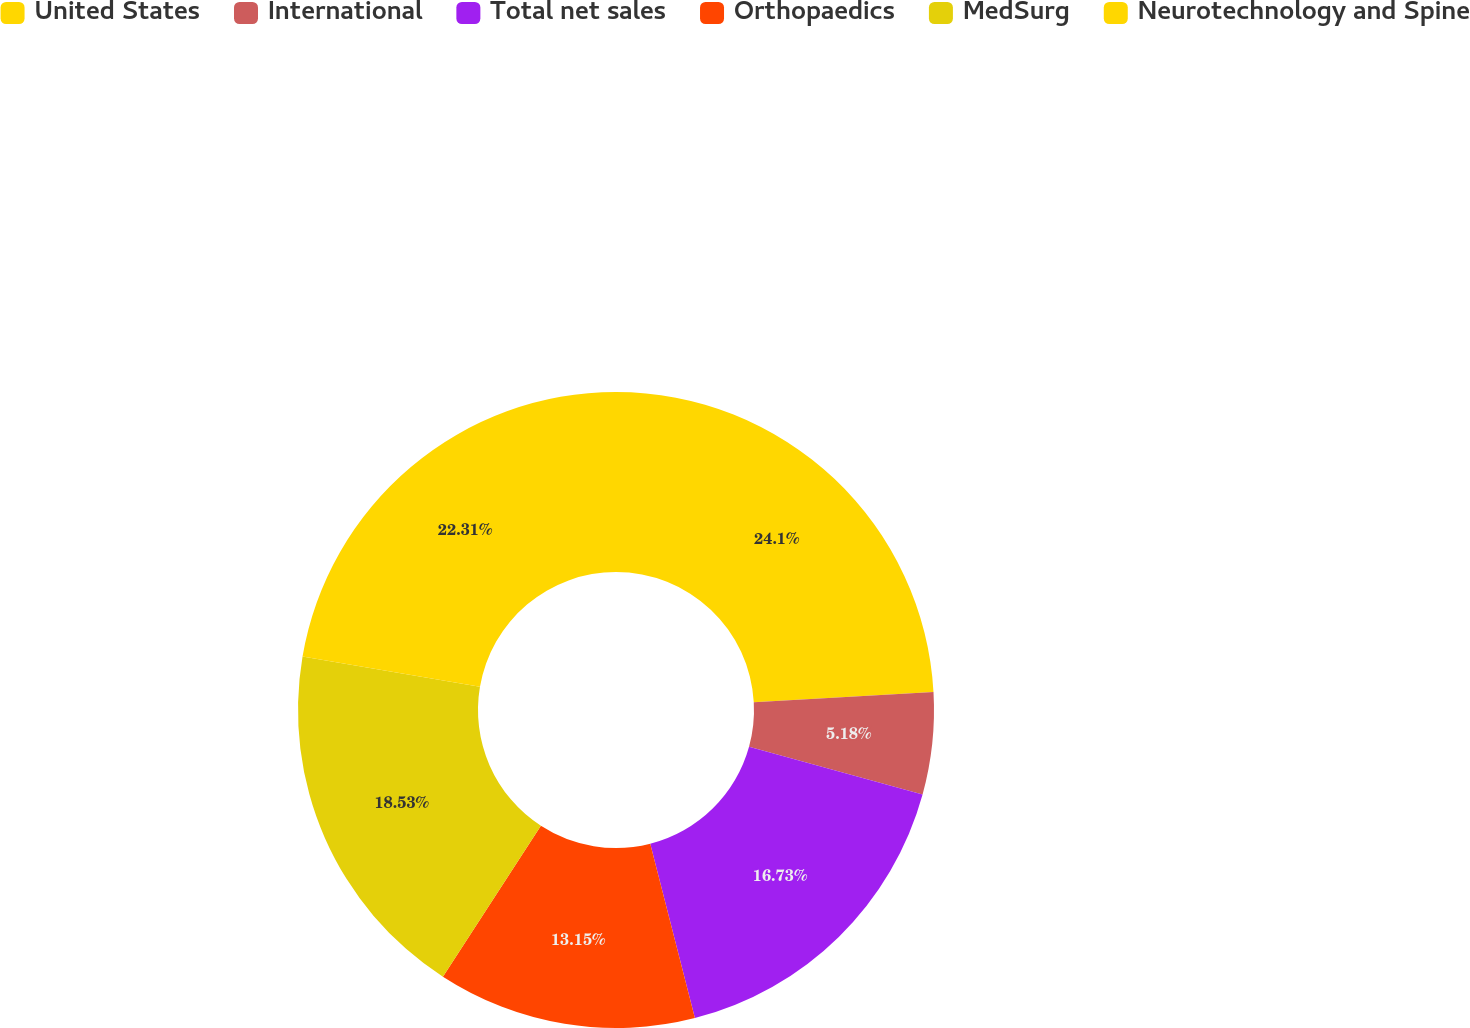<chart> <loc_0><loc_0><loc_500><loc_500><pie_chart><fcel>United States<fcel>International<fcel>Total net sales<fcel>Orthopaedics<fcel>MedSurg<fcel>Neurotechnology and Spine<nl><fcel>24.1%<fcel>5.18%<fcel>16.73%<fcel>13.15%<fcel>18.53%<fcel>22.31%<nl></chart> 